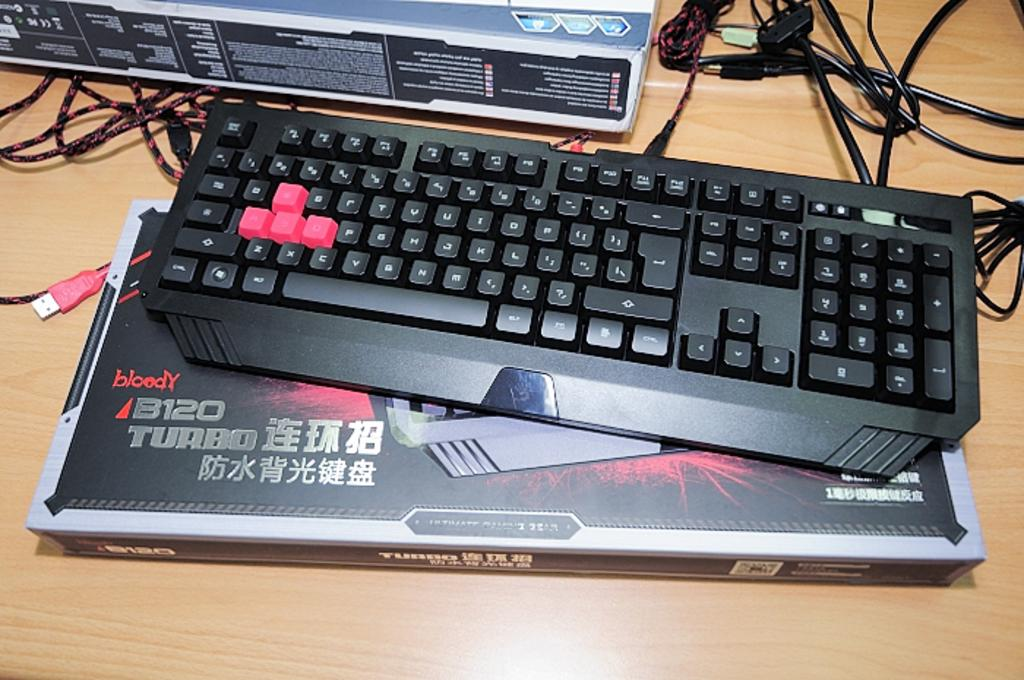What electronic device is visible in the image? There is a keyboard in the image. Where is the keyboard placed? The keyboard is on a box. What else can be seen on the table in the image? There is another box on the table. What items are present beside the box? Wires and USB cables are present beside the box. How many branches are visible on the keyboard in the image? There are no branches visible on the keyboard in the image, as it is an electronic device and not a tree or plant. 